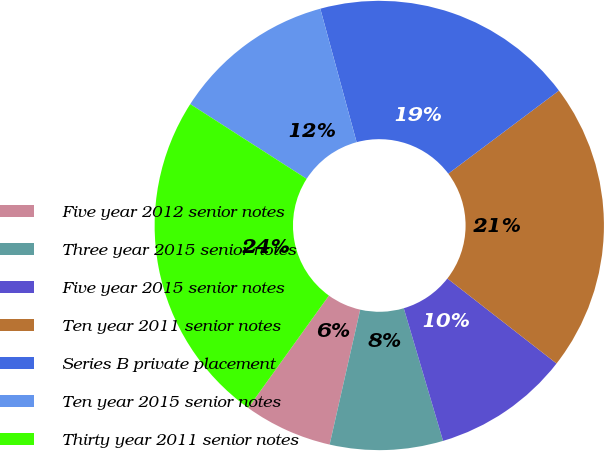<chart> <loc_0><loc_0><loc_500><loc_500><pie_chart><fcel>Five year 2012 senior notes<fcel>Three year 2015 senior notes<fcel>Five year 2015 senior notes<fcel>Ten year 2011 senior notes<fcel>Series B private placement<fcel>Ten year 2015 senior notes<fcel>Thirty year 2011 senior notes<nl><fcel>6.37%<fcel>8.13%<fcel>9.89%<fcel>20.78%<fcel>18.98%<fcel>11.69%<fcel>24.17%<nl></chart> 